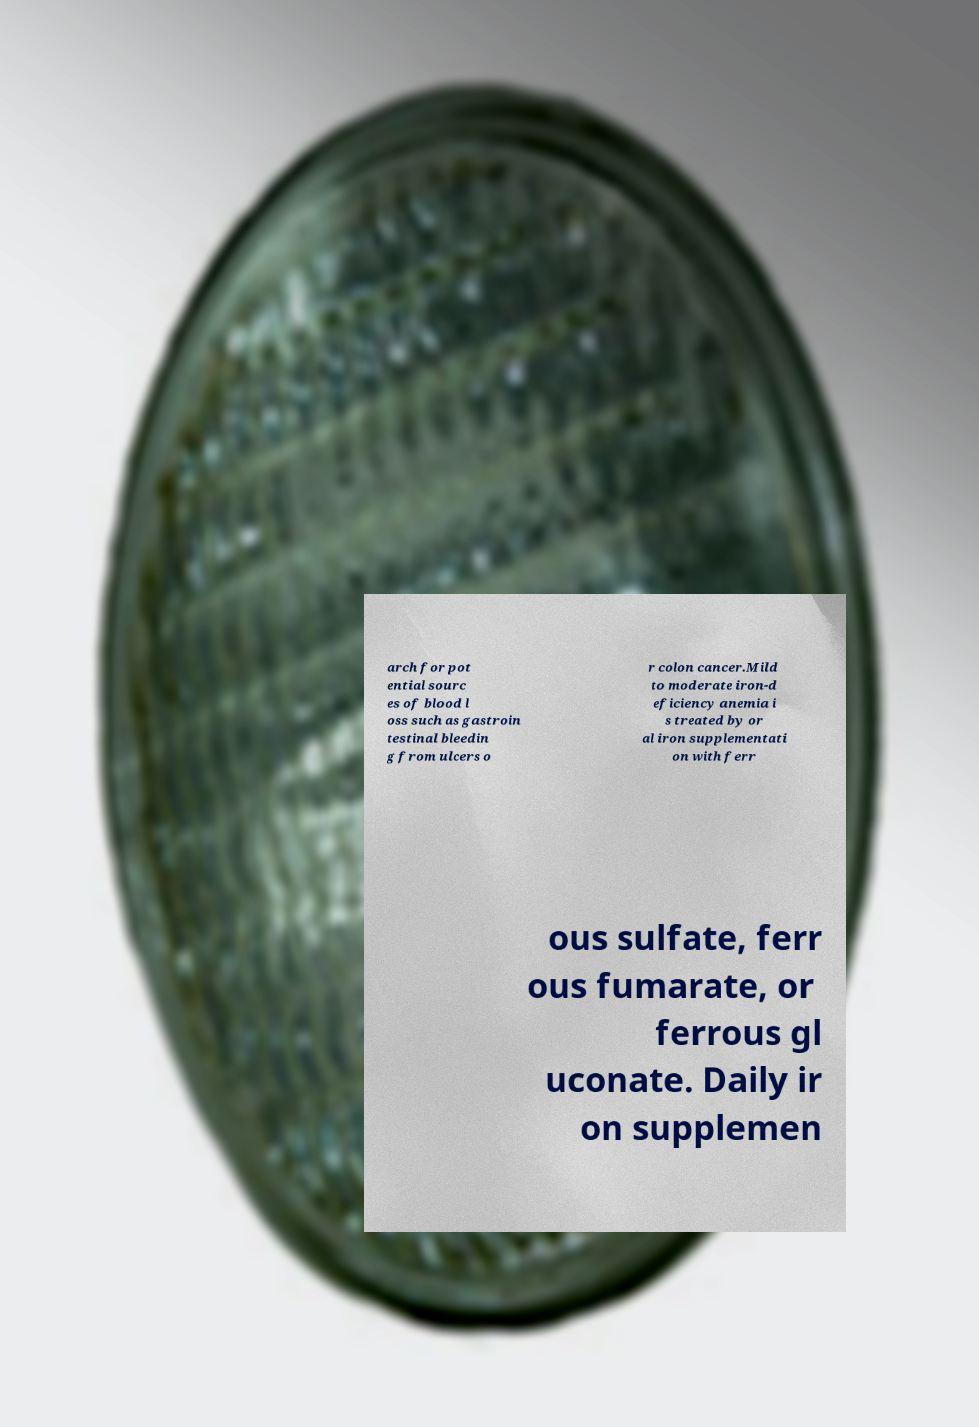For documentation purposes, I need the text within this image transcribed. Could you provide that? arch for pot ential sourc es of blood l oss such as gastroin testinal bleedin g from ulcers o r colon cancer.Mild to moderate iron-d eficiency anemia i s treated by or al iron supplementati on with ferr ous sulfate, ferr ous fumarate, or ferrous gl uconate. Daily ir on supplemen 